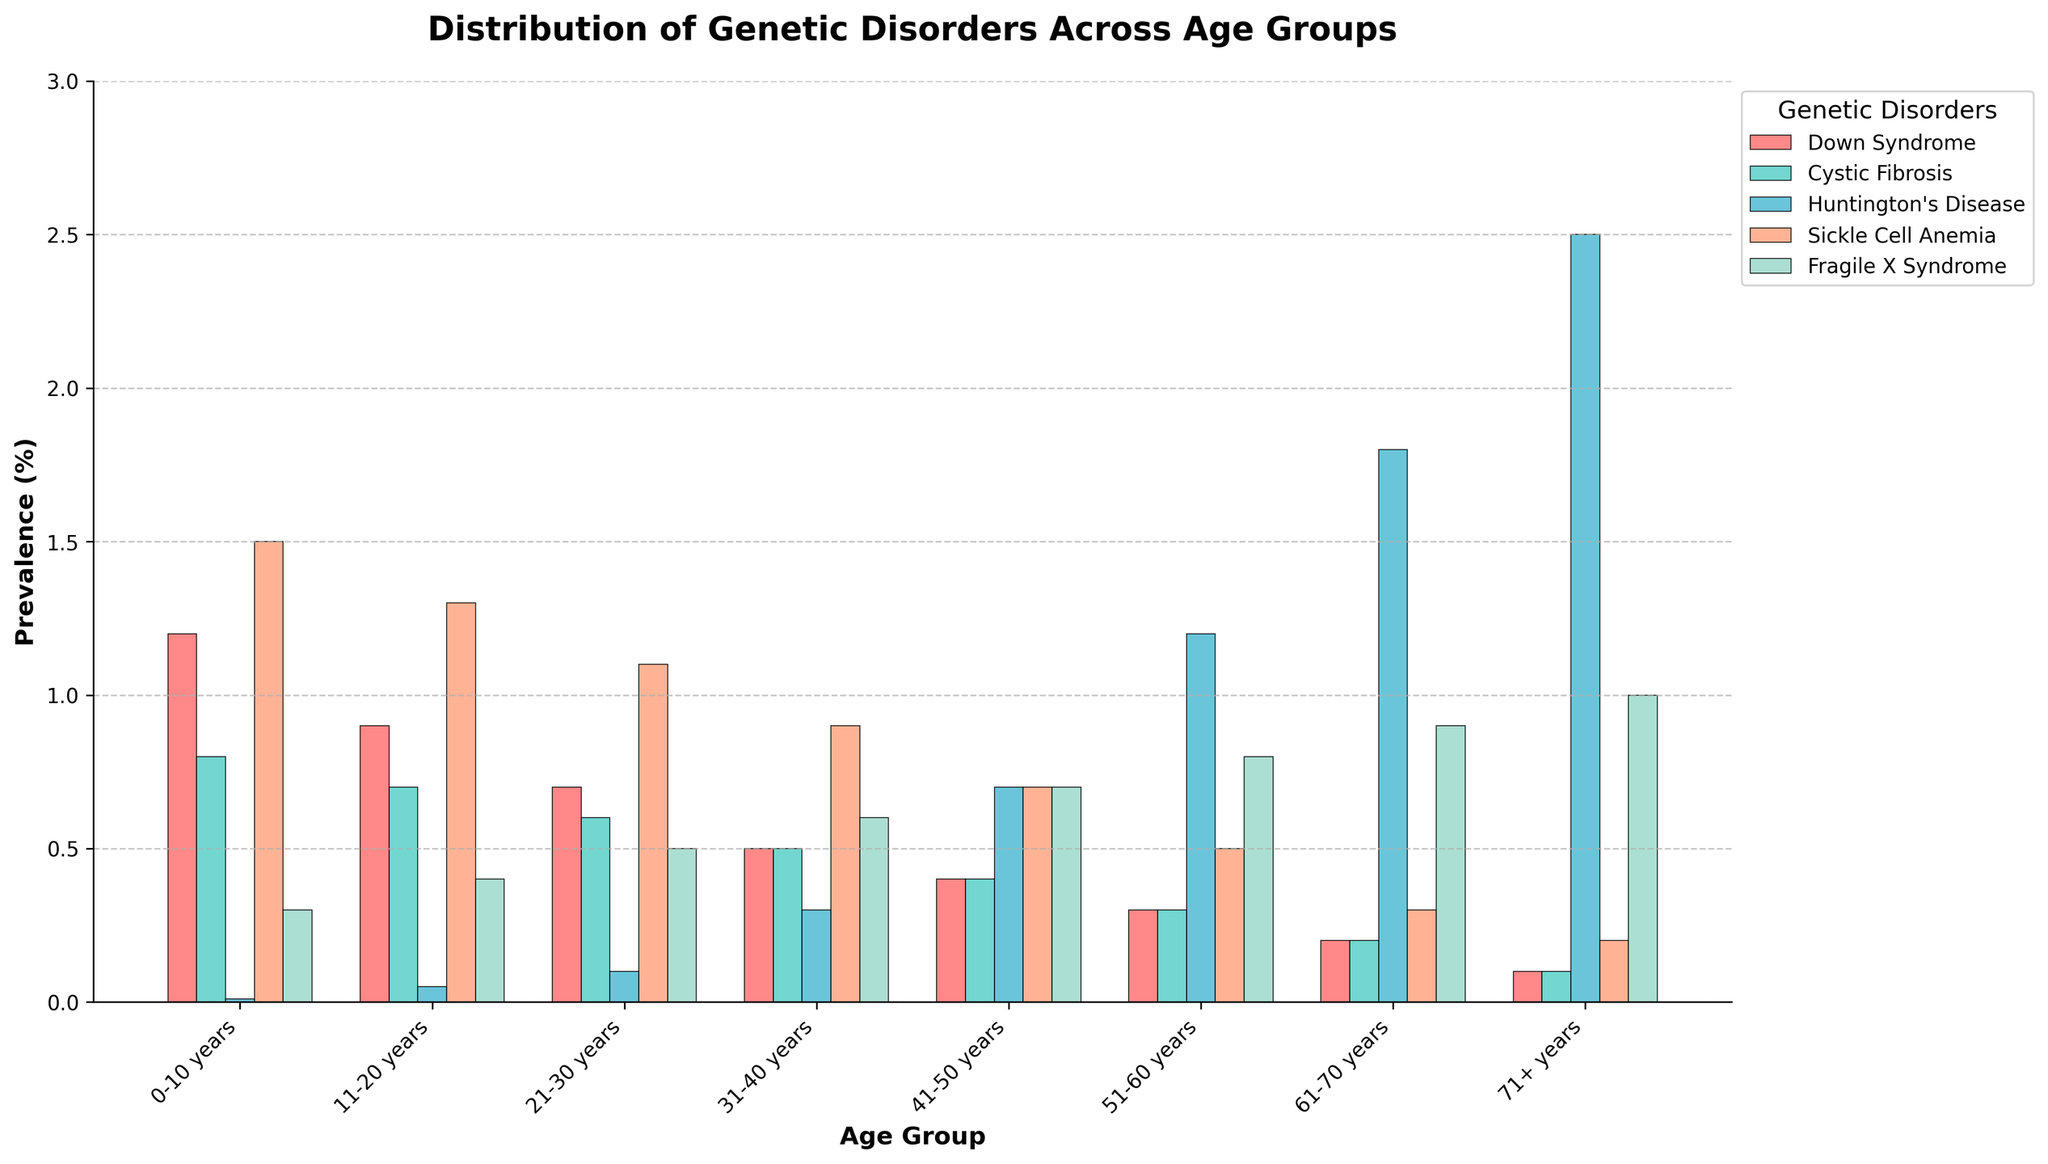What is the prevalence of Down Syndrome in the age group 0-10 years? The bar for Down Syndrome in the 0-10 years age group is at 1.2% on the y-axis.
Answer: 1.2% In which age group is Huntington's Disease most prevalent? The highest bar for Huntington's Disease is in the 71+ years age group, reaching up to 2.5% on the y-axis.
Answer: 71+ years Compare the prevalence of Sickle Cell Anemia between the 0-10 years and 51-60 years age groups. The bar for Sickle Cell Anemia in the 0-10 years group is at 1.5%, and in the 51-60 years group, it's at 0.5%. Hence, it's higher in the 0-10 years group.
Answer: 0-10 years What's the sum of the prevalence rates of Cystic Fibrosis across all age groups? Summing up the prevalence rates: 0.8 + 0.7 + 0.6 + 0.5 + 0.4 + 0.3 + 0.2 + 0.1 = 3.6
Answer: 3.6% Which disorder consistently decreases in prevalence as age increases? By visually inspecting the bars for each disorder across age groups, Down Syndrome consistently decreases from 0-10 years (1.2%) to 71+ years (0.1%).
Answer: Down Syndrome What is the difference in prevalence of Fragile X Syndrome between the 41-50 years and 71+ years age groups? The bar for Fragile X Syndrome in the 41-50 years group is at 0.7%, and in the 71+ years group, it's at 1.0%. The difference is 1.0% - 0.7% = 0.3%.
Answer: 0.3% How many age groups have a prevalence of Huntington’s Disease above 1%? Inspecting the bars for Huntington's Disease, the age groups 51-60 years (1.2%), 61-70 years (1.8%), and 71+ years (2.5%) have a prevalence above 1%. Therefore, there are 3 age groups.
Answer: 3 What's the average prevalence of Cystic Fibrosis across all age groups? Summing up the prevalence rates of Cystic Fibrosis across all age groups is 3.6%, and there are 8 age groups. So, 3.6 / 8 = 0.45%.
Answer: 0.45% Compare the combined prevalence of Down Syndrome and Sickle Cell Anemia in the 0-10 years age group. The prevalence of Down Syndrome is 1.2%, and Sickle Cell Anemia is 1.5%. Combining them gives 1.2 + 1.5 = 2.7%.
Answer: 2.7% Which age group has the least prevalence of any genetic disorder? The minimum combined bar heights for any age group appear to be in the 71+ years group, with all individual disorders being at their lowest comparative values.
Answer: 71+ years 